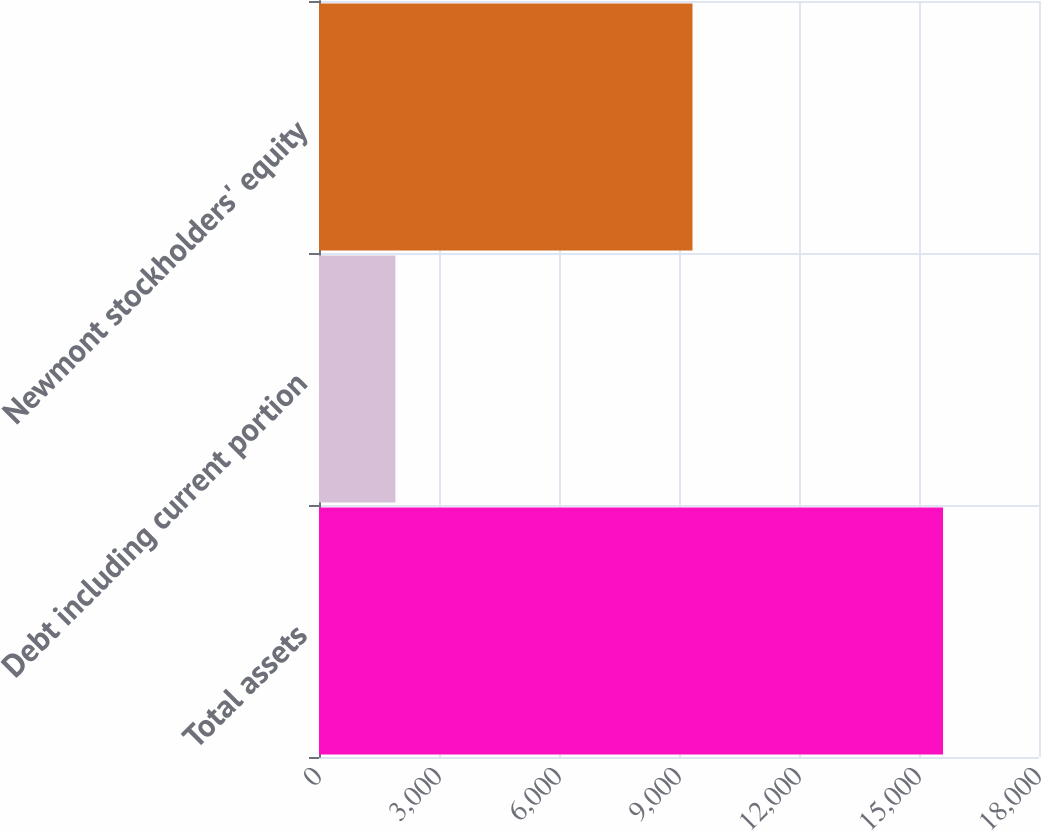Convert chart. <chart><loc_0><loc_0><loc_500><loc_500><bar_chart><fcel>Total assets<fcel>Debt including current portion<fcel>Newmont stockholders' equity<nl><fcel>15601<fcel>1911<fcel>9337<nl></chart> 